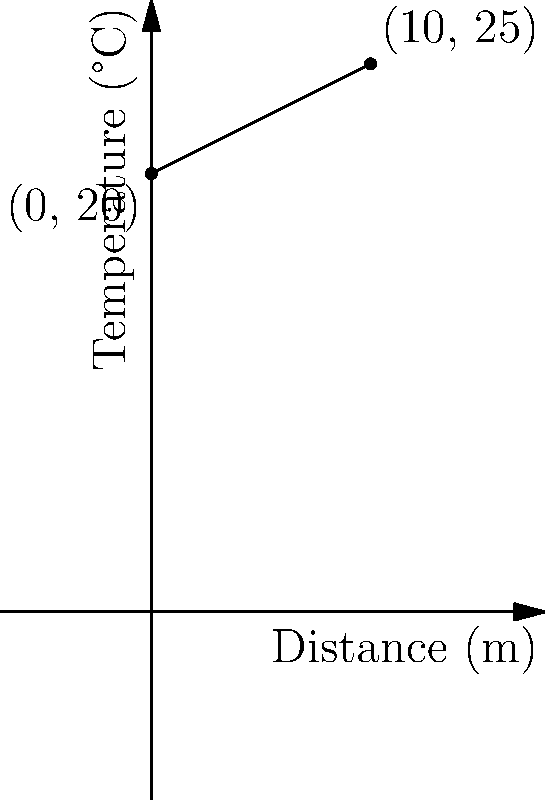As a process operator, you're monitoring a heat exchanger's temperature gradient. The engineer has provided a graph showing the temperature change across the exchanger's length. Given that the temperature at the inlet (0 m) is 20°C and at the outlet (10 m) is 25°C, calculate the slope of the temperature gradient line. What does this slope represent in terms of heat transfer? To calculate the slope of the temperature gradient line, we'll follow these steps:

1) The slope formula is:
   $$ m = \frac{y_2 - y_1}{x_2 - x_1} $$
   where $(x_1, y_1)$ is the first point and $(x_2, y_2)$ is the second point.

2) From the graph, we can identify two points:
   - Inlet: $(0, 20)$
   - Outlet: $(10, 25)$

3) Let's plug these into our formula:
   $$ m = \frac{25 - 20}{10 - 0} = \frac{5}{10} = 0.5 $$

4) The slope is 0.5 °C/m.

5) In terms of heat transfer, this slope represents the temperature change rate along the length of the heat exchanger. Specifically, it shows that the temperature increases by 0.5°C for every meter along the exchanger.

6) This positive slope indicates that heat is being transferred from the hot fluid to the cold fluid in the exchanger, as the temperature is increasing along its length.
Answer: 0.5 °C/m, representing the temperature increase rate along the heat exchanger. 